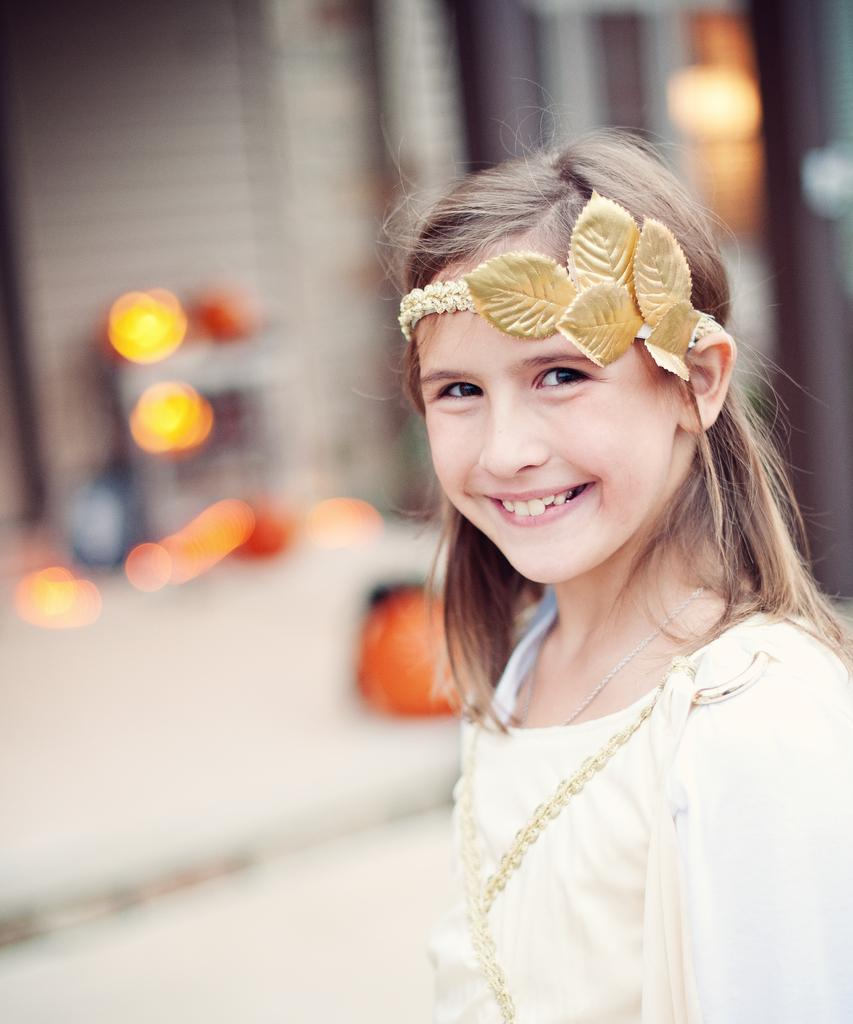Who is the main subject in the image? There is a girl in the image. What is the girl doing in the image? The girl is smiling. Can you describe the background of the image? The background of the image is blurred. What type of bead is hanging from the girl's neck in the image? There is no bead visible in the image. What time is displayed on the clock in the image? There is no clock present in the image. 